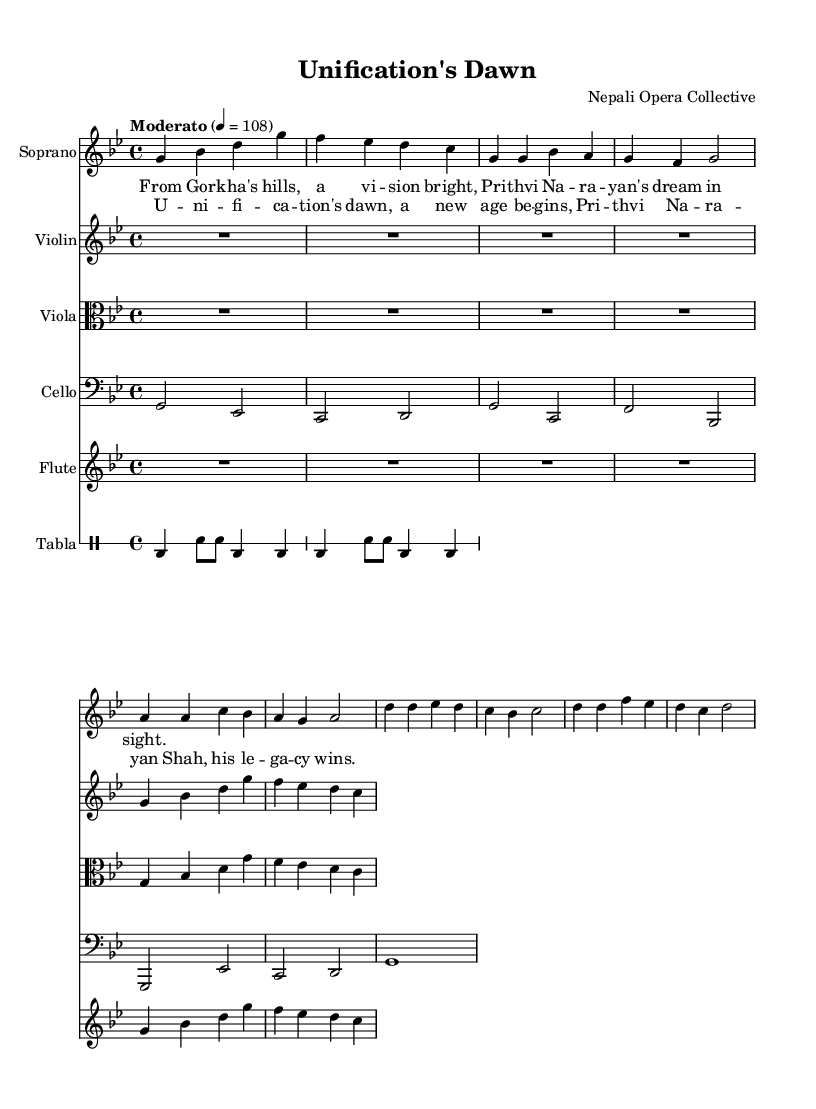What is the key signature of this music? The key signature is G minor, which is indicated by two flats (B♭ and E♭) in the staff at the beginning of the music.
Answer: G minor What is the time signature of this music? The time signature is 4/4, which is specified at the beginning of the score and indicates that there are four beats per measure.
Answer: 4/4 What is the tempo marking of this piece? The tempo marking is "Moderato," which typically indicates a moderate pace, and it's noted at the beginning with a metronome marking of 108 beats per minute.
Answer: Moderato How many instruments are featured in this opera? The score includes five distinct instruments: Soprano, Violin, Viola, Cello, and Flute, along with a DrumStaff for Tabla, making a total of six instruments.
Answer: Six What thematic content can be inferred from the lyrics? The lyrics reflect the themes of unification and the legacy of Prithvi Narayan Shah, suggesting the historical significance of his actions in unifying Nepal, as depicted in the verses and chorus present in the score.
Answer: Unification of Nepal What is the role of the Tabla in this opera? The Tabla provides rhythmic accompaniment in the percussion section, which is essential for maintaining the beat and enhancing the cultural context of the opera, particularly reflective of South Asian music traditions.
Answer: Rhythmic accompaniment What form does the opera predominantly follow based on the content provided? The opera follows a lyrical and melodic structure, as indicated by the presence of verses and choruses interspersed with instrumental sections, typical of operatic compositions.
Answer: Lyrical and melodic structure 